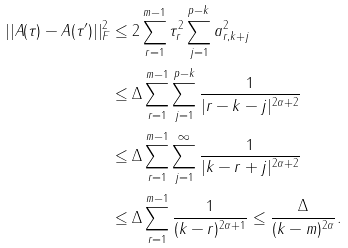<formula> <loc_0><loc_0><loc_500><loc_500>| | A ( \tau ) - A ( \tau ^ { \prime } ) | | ^ { 2 } _ { F } & \leq 2 \sum _ { r = 1 } ^ { m - 1 } \tau _ { r } ^ { 2 } \sum _ { j = 1 } ^ { p - k } a _ { r , k + j } ^ { 2 } \\ & \leq \Delta \sum _ { r = 1 } ^ { m - 1 } \sum _ { j = 1 } ^ { p - k } \frac { 1 } { | r - k - j | ^ { 2 \alpha + 2 } } \\ & \leq \Delta \sum _ { r = 1 } ^ { m - 1 } \sum _ { j = 1 } ^ { \infty } \frac { 1 } { | k - r + j | ^ { 2 \alpha + 2 } } \\ & \leq \Delta \sum _ { r = 1 } ^ { m - 1 } \frac { 1 } { ( k - r ) ^ { 2 \alpha + 1 } } \leq \frac { \Delta } { ( k - m ) ^ { 2 \alpha } } .</formula> 